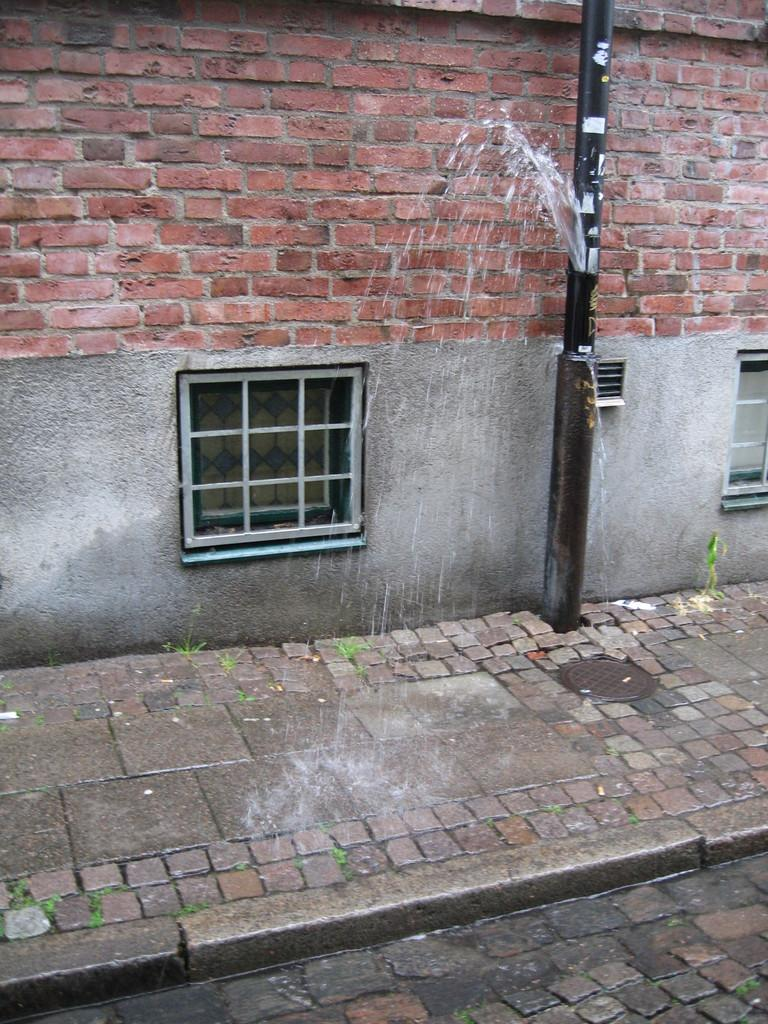What is the main object in the middle of the image? There is a pole in the middle of the image. What is behind the pole? There is a wall behind the pole. What can be seen on the wall? There are windows on the wall. What type of quill is being used to create a rhythm on the wall in the image? There is no quill or rhythm present in the image; it only features a pole, a wall, and windows. 